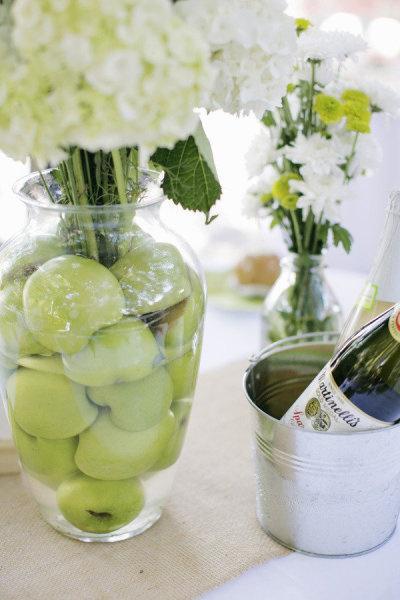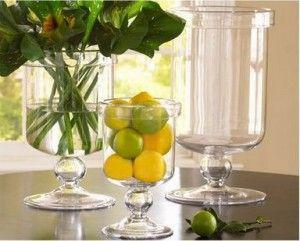The first image is the image on the left, the second image is the image on the right. Assess this claim about the two images: "All images show exactly three glass containers containing candles and/or greenery.". Correct or not? Answer yes or no. No. The first image is the image on the left, the second image is the image on the right. For the images shown, is this caption "The combined images include a clear container filled with lemons and one filled with apples." true? Answer yes or no. Yes. 